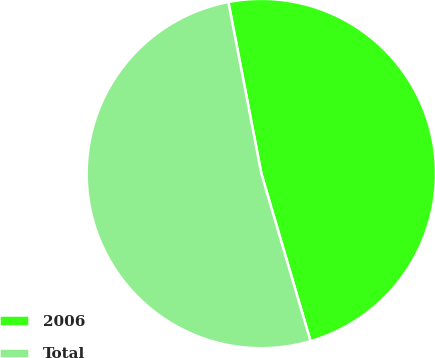Convert chart. <chart><loc_0><loc_0><loc_500><loc_500><pie_chart><fcel>2006<fcel>Total<nl><fcel>48.48%<fcel>51.52%<nl></chart> 